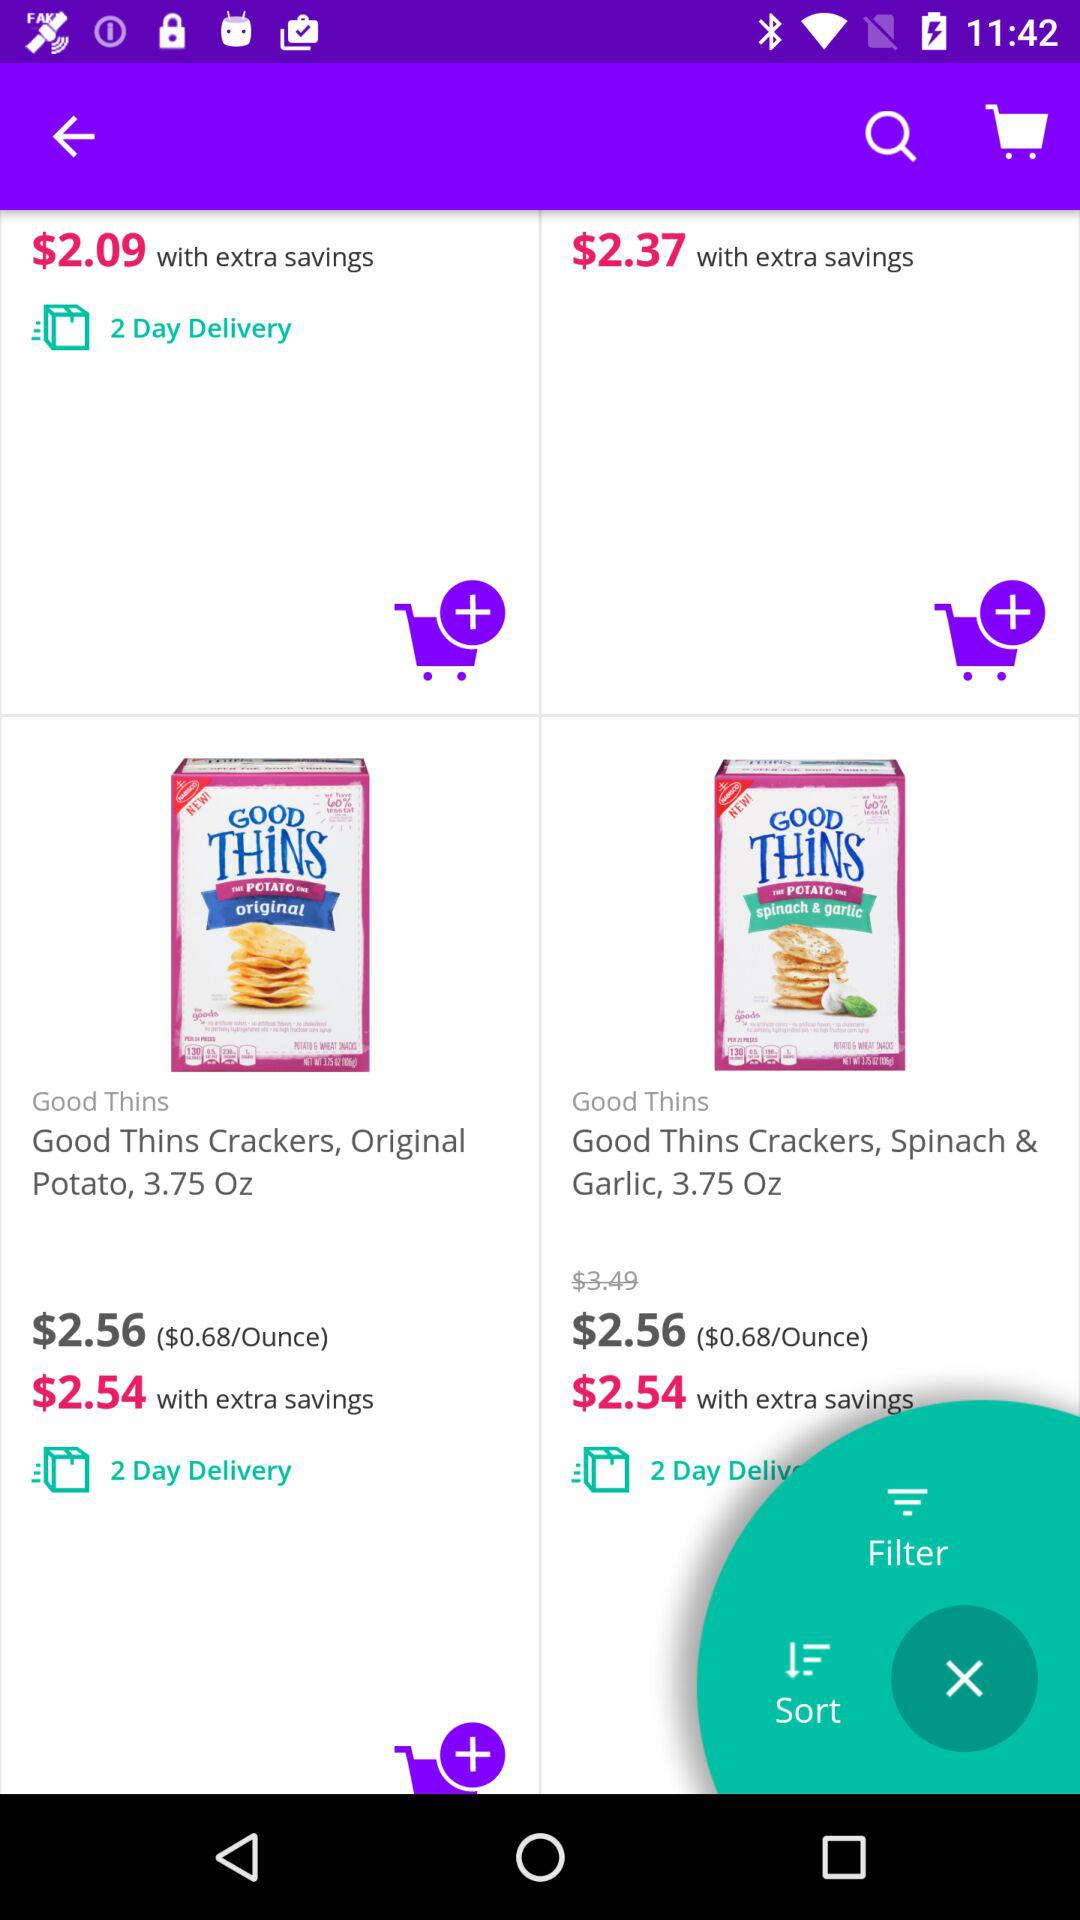What is the price of "Good Thins Crackers, Original Potato" before saving? The price is $2.56. 